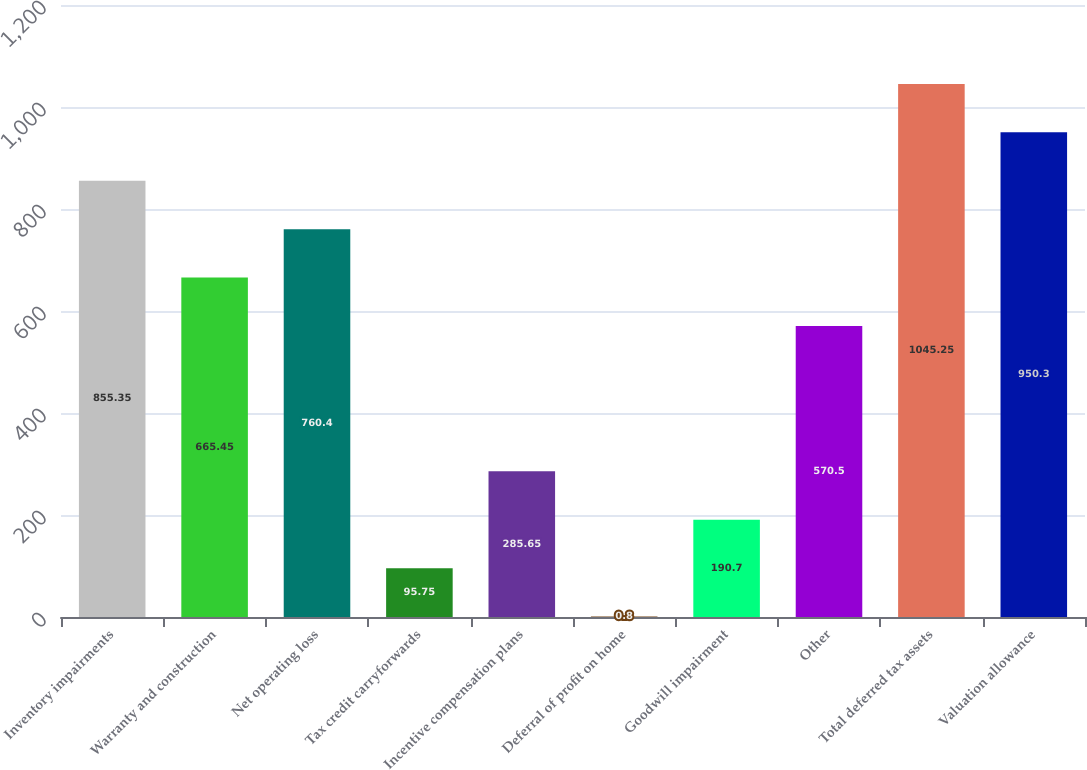<chart> <loc_0><loc_0><loc_500><loc_500><bar_chart><fcel>Inventory impairments<fcel>Warranty and construction<fcel>Net operating loss<fcel>Tax credit carryforwards<fcel>Incentive compensation plans<fcel>Deferral of profit on home<fcel>Goodwill impairment<fcel>Other<fcel>Total deferred tax assets<fcel>Valuation allowance<nl><fcel>855.35<fcel>665.45<fcel>760.4<fcel>95.75<fcel>285.65<fcel>0.8<fcel>190.7<fcel>570.5<fcel>1045.25<fcel>950.3<nl></chart> 